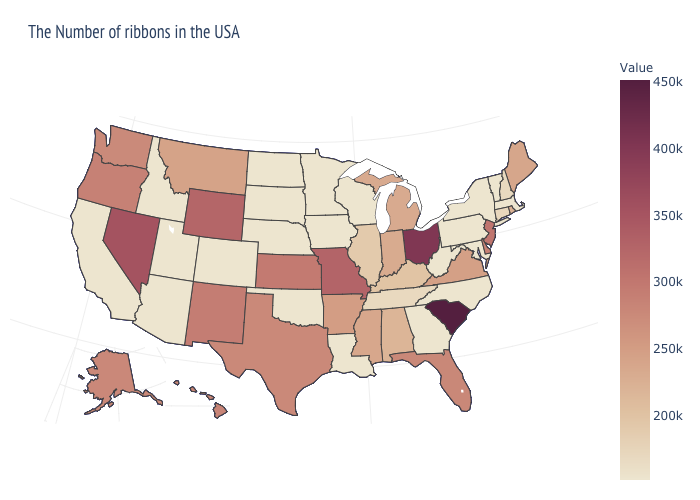Which states have the lowest value in the MidWest?
Write a very short answer. Wisconsin, Minnesota, Iowa, Nebraska, South Dakota, North Dakota. Does Rhode Island have a lower value than Utah?
Answer briefly. No. 